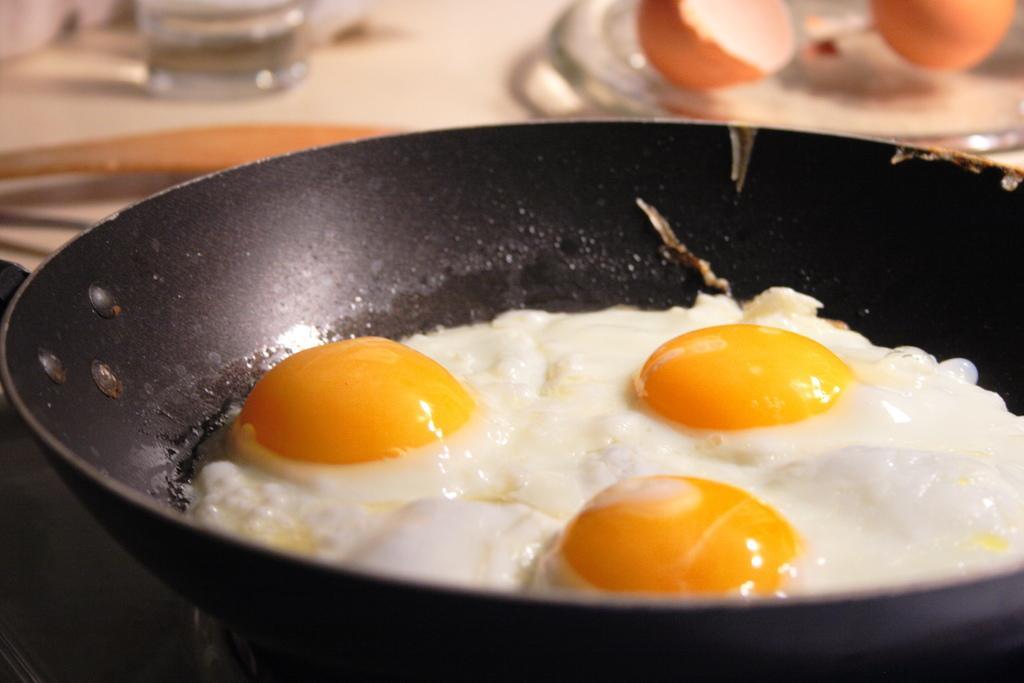Describe this image in one or two sentences. In this picture we can see a pan with food in it, glass with water in it, plate with eggs on it, spoon and these all are placed on a platform. 